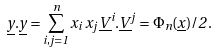<formula> <loc_0><loc_0><loc_500><loc_500>\underline { y } . \underline { y } = \sum _ { i , j = 1 } ^ { n } x _ { i } \, x _ { j } \, \underline { V } ^ { i } . \underline { V } ^ { j } = \Phi _ { n } ( \underline { x } ) / 2 \, .</formula> 